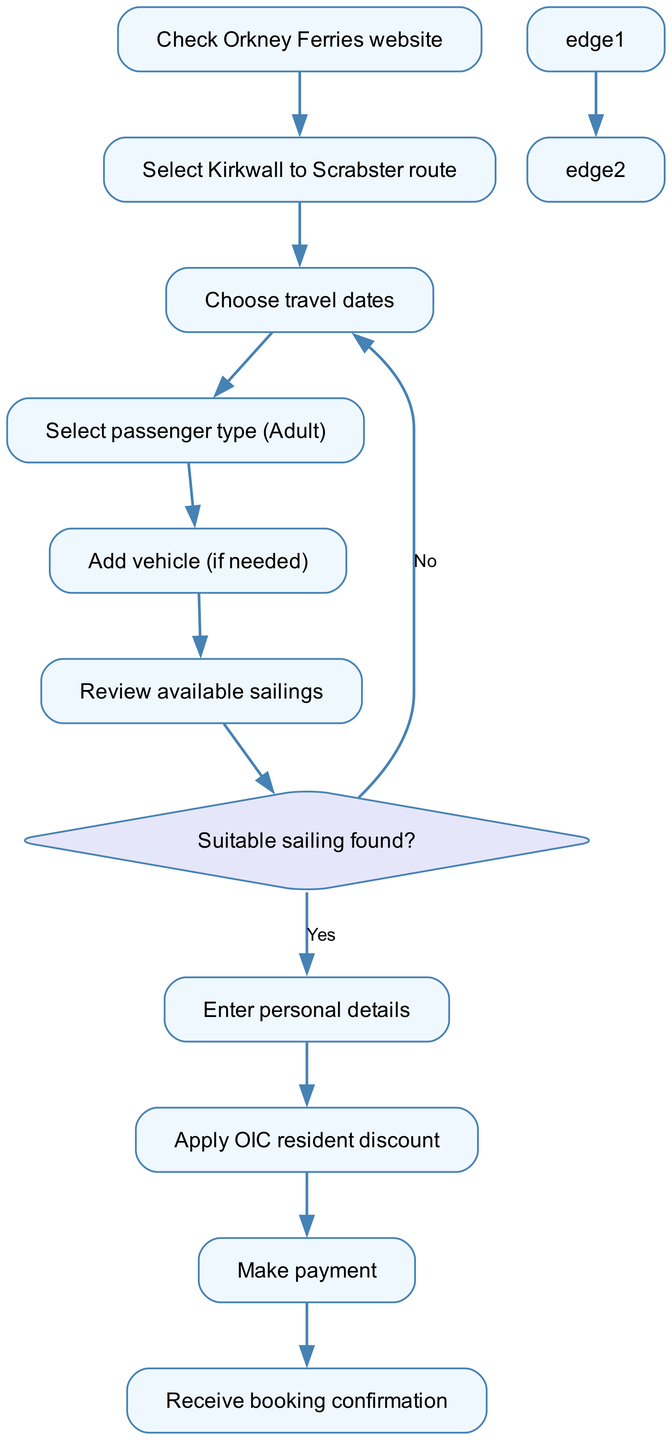What's the first step in the ferry booking process? The first step in the diagram is to "Check Orkney Ferries website". This is indicated as the starting node in the flowchart.
Answer: Check Orkney Ferries website How many steps are there in the process? Counting all the steps from the starting node to the end node, there are eight steps — from checking the website to receiving booking confirmation.
Answer: Eight What type of node follows the "Review available sailings" step? After "Review available sailings", a decision node labeled "Suitable sailing found?" follows, indicating whether a suitable option has been identified.
Answer: Decision node What happens if a suitable sailing is not found? If a suitable sailing is not found, the flow goes back to the "Choose travel dates" step, as indicated by the edge labeled "No." This suggests that the user needs to try different travel dates.
Answer: Go back to "Choose travel dates" What is the last action taken in the ferry booking process? The last action is to "Receive booking confirmation", which is the final step in the flowchart, indicating the completion of the booking process.
Answer: Receive booking confirmation Which discount can be applied before making payment? The discount that can be applied is the "OIC resident discount", which comes after entering personal details in the flowchart.
Answer: OIC resident discount What is the relationship between "Select passenger type (Adult)" and "Add vehicle (if needed)"? "Select passenger type (Adult)" is followed directly by "Add vehicle (if needed)" indicating that this step can occur right after specifying the passenger type in the booking process.
Answer: They are consecutive steps If you find a suitable sailing, what is the next step? If a suitable sailing is found, the next step is to "Enter personal details," as indicated by the edge that follows the decision node labeled "Yes."
Answer: Enter personal details 